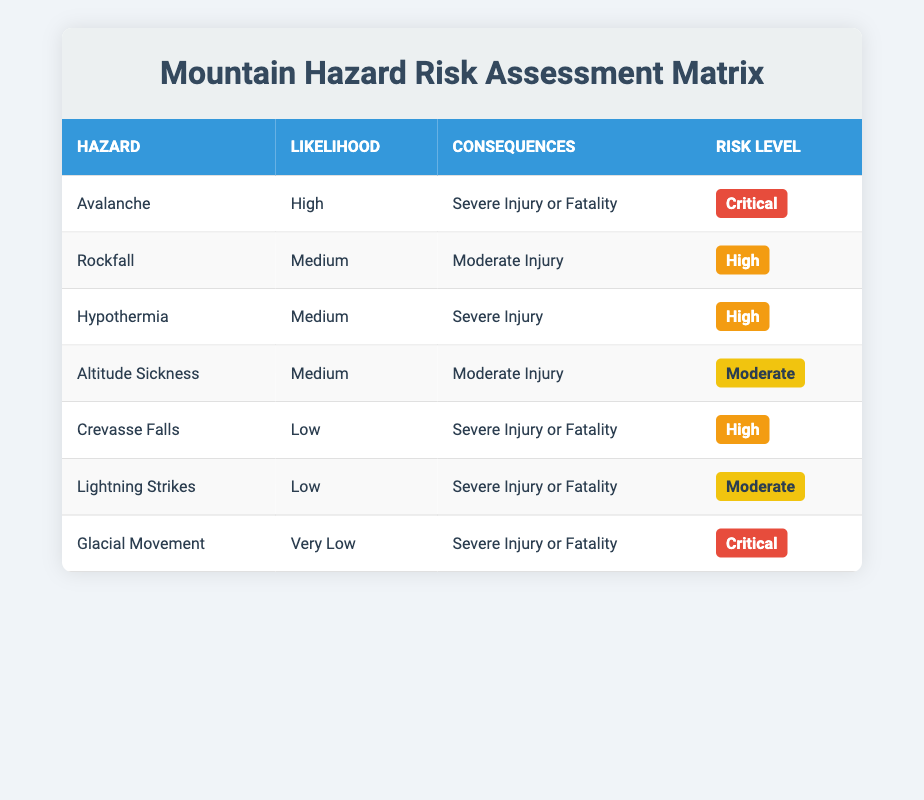What hazard is assessed as having a "High" risk level? Looking at the Risk Level column, "High" risk is assigned to Rockfall, Hypothermia, and Crevasse Falls.
Answer: Rockfall, Hypothermia, Crevasse Falls Is Avalanche the hazard with the most severe consequences? Yes, Avalanche is listed as leading to "Severe Injury or Fatality," which are the most severe consequences in the table.
Answer: Yes What is the likelihood of experiencing Altitude Sickness? Altitude Sickness is categorized as having a "Medium" likelihood according to the Likelihood column of the table.
Answer: Medium How many hazards have a consequence of "Severe Injury or Fatality"? By counting the rows in the Consequences column, Avalanche, Crevasse Falls, Lightning Strikes, and Glacial Movement all have the consequence of "Severe Injury or Fatality," which is four hazards.
Answer: 4 Which hazard has the lowest likelihood and what is its risk level? The hazard with the lowest likelihood is Glacial Movement, which is categorized as "Very Low" and has a "Critical" risk level.
Answer: Glacial Movement, Critical Are there any hazards listed with a "Moderate" risk level? Yes, there is one hazard, Altitude Sickness, that has a "Moderate" risk level.
Answer: Yes What is the risk level of Rockfall, and what injury is expected? Rockfall is assessed with a "High" risk level and is expected to cause "Moderate Injury."
Answer: High, Moderate Injury Considering all hazards, what is the average risk level considering that Critical = 3, High = 2, Moderate = 1? There are two Critical (Avalanche, Glacial Movement), three High (Rockfall, Hypothermia, Crevasse Falls), and two Moderate (Altitude Sickness, Lightning Strikes). Calculating the average: (2*3 + 3*2 + 2*1) / 7 = 18 / 7 = 2.57, which translates to slightly High.
Answer: Approximately High What are the consequences of the hazard with the highest likelihood? The hazard with the highest likelihood is Avalanche, which has the consequence of "Severe Injury or Fatality."
Answer: Severe Injury or Fatality 